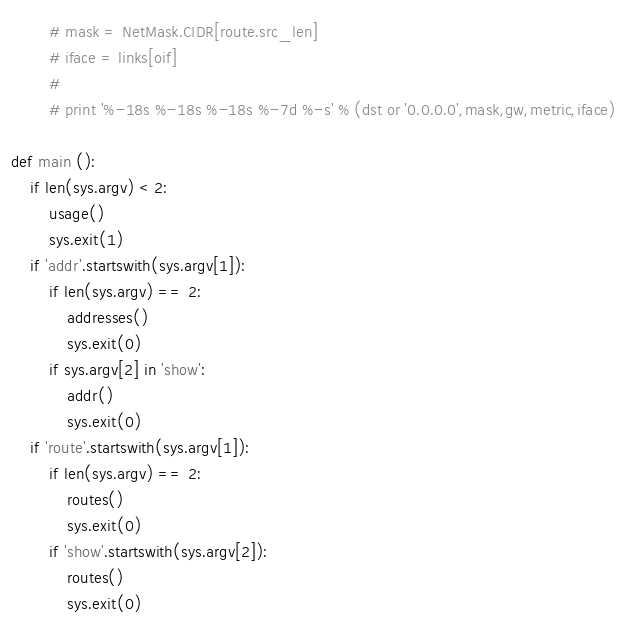<code> <loc_0><loc_0><loc_500><loc_500><_Python_>		# mask = NetMask.CIDR[route.src_len]
		# iface = links[oif]
		#
		# print '%-18s %-18s %-18s %-7d %-s' % (dst or '0.0.0.0',mask,gw,metric,iface)

def main ():
	if len(sys.argv) < 2:
		usage()
		sys.exit(1)
	if 'addr'.startswith(sys.argv[1]):
		if len(sys.argv) == 2:
			addresses()
			sys.exit(0)
		if sys.argv[2] in 'show':
			addr()
			sys.exit(0)
	if 'route'.startswith(sys.argv[1]):
		if len(sys.argv) == 2:
			routes()
			sys.exit(0)
		if 'show'.startswith(sys.argv[2]):
			routes()
			sys.exit(0)</code> 